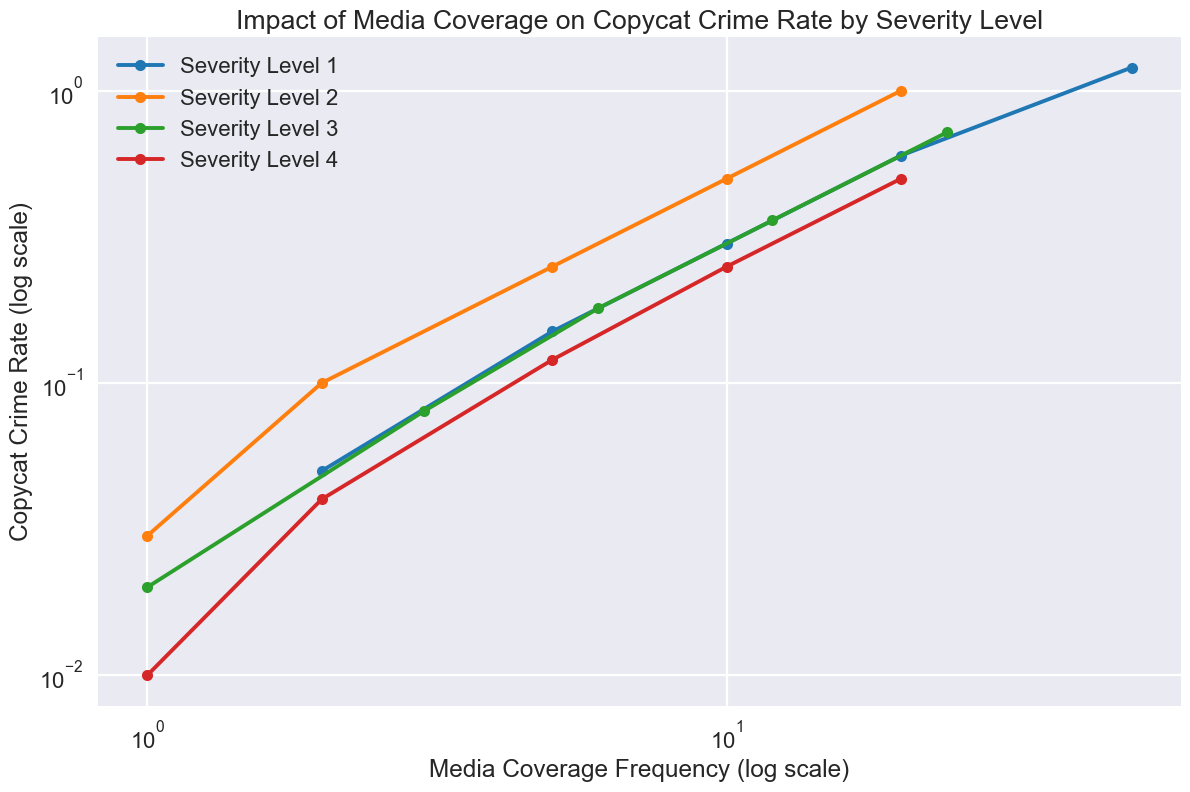Which severity level shows the fastest increase in copycat crime rate with increasing media coverage frequency? By observing the steepness of the lines, the steeper the slope, the faster the increase. Severity Level 1 shows the fastest increase as its line is the steepest among all as media coverage frequency increases.
Answer: Severity Level 1 Which severity level has the lowest copycat crime rate at the highest media coverage frequency? By locating the highest media coverage frequency (50) on the x-axis and comparing the y-values of all severity levels, Severity Level 1 has the lowest copycat crime rate at this point.
Answer: Severity Level 1 How does the copycat crime rate for Severity Level 3 at a media coverage frequency of 6 compare to Severity Level 2 at a media coverage frequency of 10? Locate both points and compare their y-values. The copycat crime rate for Severity Level 3 at frequency 6 is 0.18, whereas for Severity Level 2 at frequency 10 is 0.50, making the latter higher.
Answer: Severity Level 2 has a higher rate What is the average copycat crime rate for Severity Level 4 given the media coverage frequencies? List the copycat crime rates for Severity Level 4 (0.01, 0.04, 0.12, 0.25, 0.50), then calculate their average: (0.01 + 0.04 + 0.12 + 0.25 + 0.50) / 5 = 0.184.
Answer: 0.184 Between Severity Level 2 and Severity Level 3, which one has a higher copycat crime rate at a media coverage frequency of 20? Locate the point where the media coverage frequency is 20 for both severity levels and compare their y-values. Severity Level 2 has a rate of 1.00, while Severity Level 3 does not have a defined point at 20, so we need to extrapolate: the trend suggests Level 3's rate would be lower.
Answer: Severity Level 2 Examine the impact of doubling media coverage frequency from 5 to 10, what is the change in copycat crime rate for Severity Level 1? Find the rates at media coverage frequencies of 5 and 10 for Severity Level 1 (0.15 and 0.30). The change is 0.30 - 0.15 = 0.15.
Answer: 0.15 Compare the trend of Severity Level 4 to that of Severity Level 1; what difference is observed in their response to increasing media coverage frequency? Severity Level 1 shows a much steeper and faster increase in the copycat crime rate compared to Severity Level 4, which shows a more gradual increase.
Answer: Severity Level 1 increases faster 